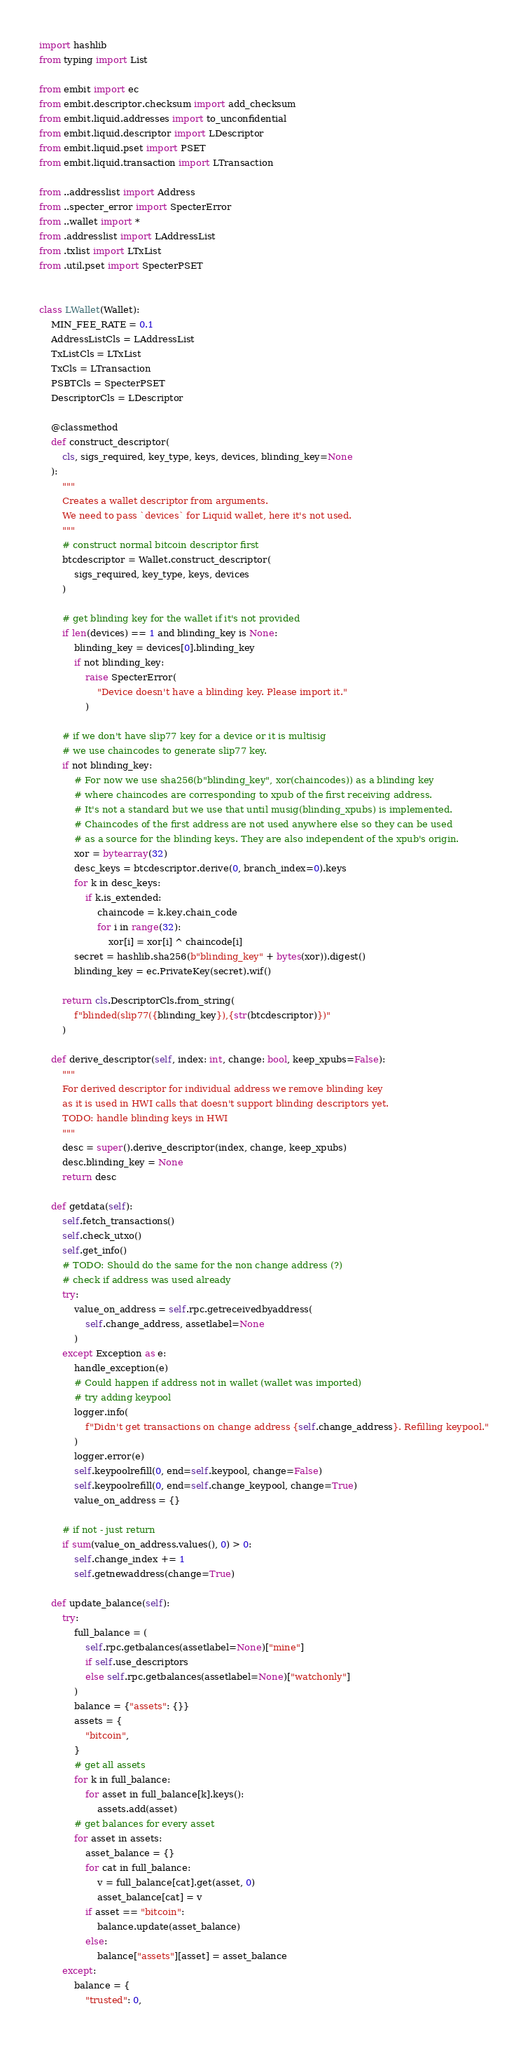Convert code to text. <code><loc_0><loc_0><loc_500><loc_500><_Python_>import hashlib
from typing import List

from embit import ec
from embit.descriptor.checksum import add_checksum
from embit.liquid.addresses import to_unconfidential
from embit.liquid.descriptor import LDescriptor
from embit.liquid.pset import PSET
from embit.liquid.transaction import LTransaction

from ..addresslist import Address
from ..specter_error import SpecterError
from ..wallet import *
from .addresslist import LAddressList
from .txlist import LTxList
from .util.pset import SpecterPSET


class LWallet(Wallet):
    MIN_FEE_RATE = 0.1
    AddressListCls = LAddressList
    TxListCls = LTxList
    TxCls = LTransaction
    PSBTCls = SpecterPSET
    DescriptorCls = LDescriptor

    @classmethod
    def construct_descriptor(
        cls, sigs_required, key_type, keys, devices, blinding_key=None
    ):
        """
        Creates a wallet descriptor from arguments.
        We need to pass `devices` for Liquid wallet, here it's not used.
        """
        # construct normal bitcoin descriptor first
        btcdescriptor = Wallet.construct_descriptor(
            sigs_required, key_type, keys, devices
        )

        # get blinding key for the wallet if it's not provided
        if len(devices) == 1 and blinding_key is None:
            blinding_key = devices[0].blinding_key
            if not blinding_key:
                raise SpecterError(
                    "Device doesn't have a blinding key. Please import it."
                )

        # if we don't have slip77 key for a device or it is multisig
        # we use chaincodes to generate slip77 key.
        if not blinding_key:
            # For now we use sha256(b"blinding_key", xor(chaincodes)) as a blinding key
            # where chaincodes are corresponding to xpub of the first receiving address.
            # It's not a standard but we use that until musig(blinding_xpubs) is implemented.
            # Chaincodes of the first address are not used anywhere else so they can be used
            # as a source for the blinding keys. They are also independent of the xpub's origin.
            xor = bytearray(32)
            desc_keys = btcdescriptor.derive(0, branch_index=0).keys
            for k in desc_keys:
                if k.is_extended:
                    chaincode = k.key.chain_code
                    for i in range(32):
                        xor[i] = xor[i] ^ chaincode[i]
            secret = hashlib.sha256(b"blinding_key" + bytes(xor)).digest()
            blinding_key = ec.PrivateKey(secret).wif()

        return cls.DescriptorCls.from_string(
            f"blinded(slip77({blinding_key}),{str(btcdescriptor)})"
        )

    def derive_descriptor(self, index: int, change: bool, keep_xpubs=False):
        """
        For derived descriptor for individual address we remove blinding key
        as it is used in HWI calls that doesn't support blinding descriptors yet.
        TODO: handle blinding keys in HWI
        """
        desc = super().derive_descriptor(index, change, keep_xpubs)
        desc.blinding_key = None
        return desc

    def getdata(self):
        self.fetch_transactions()
        self.check_utxo()
        self.get_info()
        # TODO: Should do the same for the non change address (?)
        # check if address was used already
        try:
            value_on_address = self.rpc.getreceivedbyaddress(
                self.change_address, assetlabel=None
            )
        except Exception as e:
            handle_exception(e)
            # Could happen if address not in wallet (wallet was imported)
            # try adding keypool
            logger.info(
                f"Didn't get transactions on change address {self.change_address}. Refilling keypool."
            )
            logger.error(e)
            self.keypoolrefill(0, end=self.keypool, change=False)
            self.keypoolrefill(0, end=self.change_keypool, change=True)
            value_on_address = {}

        # if not - just return
        if sum(value_on_address.values(), 0) > 0:
            self.change_index += 1
            self.getnewaddress(change=True)

    def update_balance(self):
        try:
            full_balance = (
                self.rpc.getbalances(assetlabel=None)["mine"]
                if self.use_descriptors
                else self.rpc.getbalances(assetlabel=None)["watchonly"]
            )
            balance = {"assets": {}}
            assets = {
                "bitcoin",
            }
            # get all assets
            for k in full_balance:
                for asset in full_balance[k].keys():
                    assets.add(asset)
            # get balances for every asset
            for asset in assets:
                asset_balance = {}
                for cat in full_balance:
                    v = full_balance[cat].get(asset, 0)
                    asset_balance[cat] = v
                if asset == "bitcoin":
                    balance.update(asset_balance)
                else:
                    balance["assets"][asset] = asset_balance
        except:
            balance = {
                "trusted": 0,</code> 